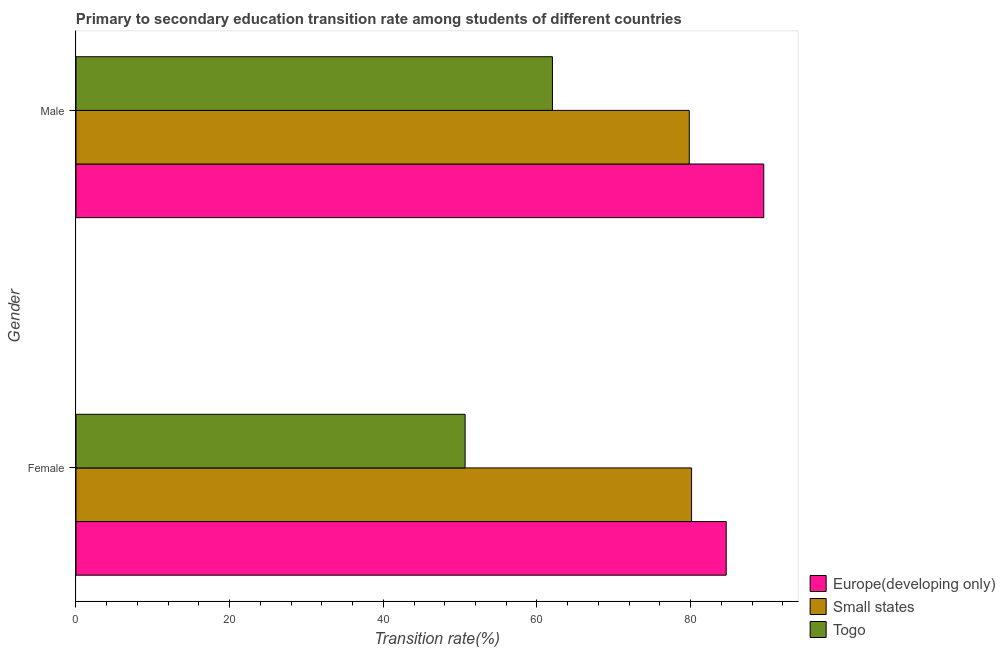Are the number of bars per tick equal to the number of legend labels?
Ensure brevity in your answer.  Yes. Are the number of bars on each tick of the Y-axis equal?
Keep it short and to the point. Yes. How many bars are there on the 2nd tick from the top?
Keep it short and to the point. 3. How many bars are there on the 2nd tick from the bottom?
Provide a short and direct response. 3. What is the transition rate among male students in Small states?
Ensure brevity in your answer.  79.83. Across all countries, what is the maximum transition rate among male students?
Your answer should be very brief. 89.52. Across all countries, what is the minimum transition rate among male students?
Make the answer very short. 62.02. In which country was the transition rate among male students maximum?
Provide a short and direct response. Europe(developing only). In which country was the transition rate among female students minimum?
Offer a very short reply. Togo. What is the total transition rate among female students in the graph?
Your response must be concise. 215.41. What is the difference between the transition rate among male students in Togo and that in Small states?
Keep it short and to the point. -17.81. What is the difference between the transition rate among female students in Europe(developing only) and the transition rate among male students in Small states?
Your response must be concise. 4.81. What is the average transition rate among female students per country?
Provide a short and direct response. 71.8. What is the difference between the transition rate among female students and transition rate among male students in Togo?
Give a very brief answer. -11.37. In how many countries, is the transition rate among female students greater than 4 %?
Your answer should be very brief. 3. What is the ratio of the transition rate among female students in Small states to that in Togo?
Make the answer very short. 1.58. In how many countries, is the transition rate among female students greater than the average transition rate among female students taken over all countries?
Your answer should be compact. 2. What does the 2nd bar from the top in Female represents?
Your answer should be compact. Small states. What does the 1st bar from the bottom in Male represents?
Offer a terse response. Europe(developing only). Are all the bars in the graph horizontal?
Give a very brief answer. Yes. How many countries are there in the graph?
Your answer should be very brief. 3. What is the difference between two consecutive major ticks on the X-axis?
Your answer should be very brief. 20. Does the graph contain any zero values?
Provide a succinct answer. No. Where does the legend appear in the graph?
Ensure brevity in your answer.  Bottom right. How many legend labels are there?
Your answer should be compact. 3. How are the legend labels stacked?
Offer a very short reply. Vertical. What is the title of the graph?
Your answer should be compact. Primary to secondary education transition rate among students of different countries. Does "Lithuania" appear as one of the legend labels in the graph?
Offer a very short reply. No. What is the label or title of the X-axis?
Provide a succinct answer. Transition rate(%). What is the label or title of the Y-axis?
Provide a succinct answer. Gender. What is the Transition rate(%) of Europe(developing only) in Female?
Offer a very short reply. 84.63. What is the Transition rate(%) in Small states in Female?
Give a very brief answer. 80.13. What is the Transition rate(%) in Togo in Female?
Offer a very short reply. 50.65. What is the Transition rate(%) in Europe(developing only) in Male?
Provide a succinct answer. 89.52. What is the Transition rate(%) in Small states in Male?
Ensure brevity in your answer.  79.83. What is the Transition rate(%) of Togo in Male?
Keep it short and to the point. 62.02. Across all Gender, what is the maximum Transition rate(%) of Europe(developing only)?
Your answer should be compact. 89.52. Across all Gender, what is the maximum Transition rate(%) in Small states?
Your answer should be compact. 80.13. Across all Gender, what is the maximum Transition rate(%) in Togo?
Make the answer very short. 62.02. Across all Gender, what is the minimum Transition rate(%) of Europe(developing only)?
Offer a very short reply. 84.63. Across all Gender, what is the minimum Transition rate(%) of Small states?
Your response must be concise. 79.83. Across all Gender, what is the minimum Transition rate(%) of Togo?
Offer a terse response. 50.65. What is the total Transition rate(%) of Europe(developing only) in the graph?
Your answer should be very brief. 174.16. What is the total Transition rate(%) of Small states in the graph?
Your answer should be very brief. 159.96. What is the total Transition rate(%) in Togo in the graph?
Your response must be concise. 112.67. What is the difference between the Transition rate(%) in Europe(developing only) in Female and that in Male?
Ensure brevity in your answer.  -4.89. What is the difference between the Transition rate(%) of Small states in Female and that in Male?
Provide a succinct answer. 0.3. What is the difference between the Transition rate(%) of Togo in Female and that in Male?
Your answer should be compact. -11.37. What is the difference between the Transition rate(%) in Europe(developing only) in Female and the Transition rate(%) in Small states in Male?
Keep it short and to the point. 4.81. What is the difference between the Transition rate(%) in Europe(developing only) in Female and the Transition rate(%) in Togo in Male?
Make the answer very short. 22.62. What is the difference between the Transition rate(%) in Small states in Female and the Transition rate(%) in Togo in Male?
Your response must be concise. 18.11. What is the average Transition rate(%) in Europe(developing only) per Gender?
Your response must be concise. 87.08. What is the average Transition rate(%) in Small states per Gender?
Ensure brevity in your answer.  79.98. What is the average Transition rate(%) of Togo per Gender?
Your answer should be very brief. 56.33. What is the difference between the Transition rate(%) in Europe(developing only) and Transition rate(%) in Small states in Female?
Give a very brief answer. 4.51. What is the difference between the Transition rate(%) in Europe(developing only) and Transition rate(%) in Togo in Female?
Ensure brevity in your answer.  33.98. What is the difference between the Transition rate(%) in Small states and Transition rate(%) in Togo in Female?
Your answer should be compact. 29.48. What is the difference between the Transition rate(%) of Europe(developing only) and Transition rate(%) of Small states in Male?
Offer a terse response. 9.7. What is the difference between the Transition rate(%) in Europe(developing only) and Transition rate(%) in Togo in Male?
Keep it short and to the point. 27.51. What is the difference between the Transition rate(%) in Small states and Transition rate(%) in Togo in Male?
Your answer should be very brief. 17.81. What is the ratio of the Transition rate(%) in Europe(developing only) in Female to that in Male?
Provide a short and direct response. 0.95. What is the ratio of the Transition rate(%) in Togo in Female to that in Male?
Provide a short and direct response. 0.82. What is the difference between the highest and the second highest Transition rate(%) in Europe(developing only)?
Offer a very short reply. 4.89. What is the difference between the highest and the second highest Transition rate(%) in Small states?
Your response must be concise. 0.3. What is the difference between the highest and the second highest Transition rate(%) of Togo?
Make the answer very short. 11.37. What is the difference between the highest and the lowest Transition rate(%) of Europe(developing only)?
Give a very brief answer. 4.89. What is the difference between the highest and the lowest Transition rate(%) of Small states?
Provide a succinct answer. 0.3. What is the difference between the highest and the lowest Transition rate(%) of Togo?
Keep it short and to the point. 11.37. 